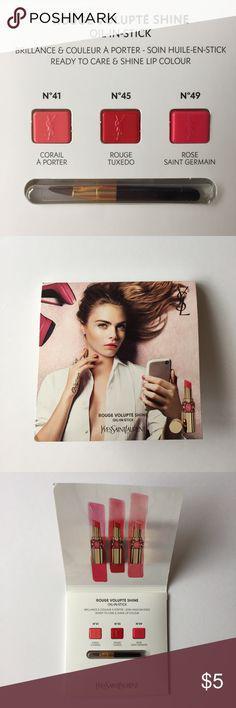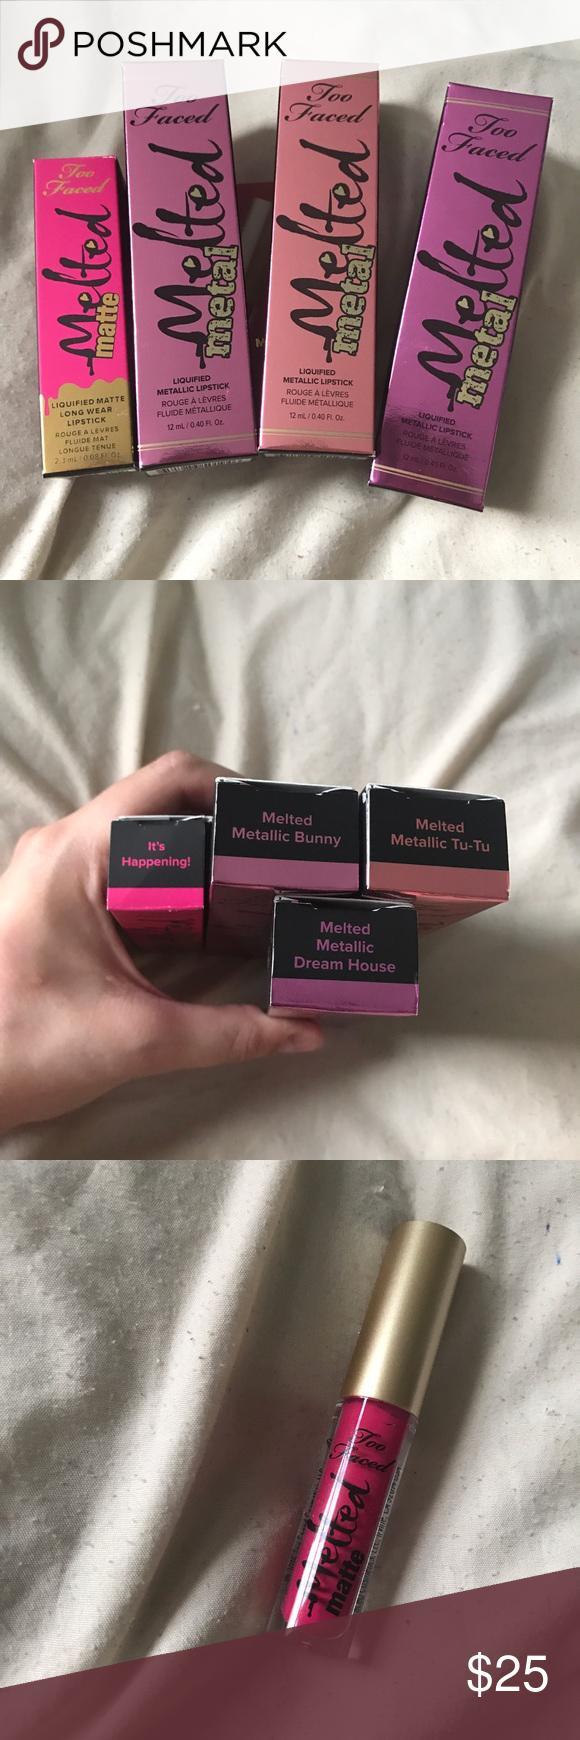The first image is the image on the left, the second image is the image on the right. For the images displayed, is the sentence "Someone is holding some lip stick." factually correct? Answer yes or no. Yes. The first image is the image on the left, the second image is the image on the right. Assess this claim about the two images: "Many shades of reddish lipstick are shown with the caps off in at least one of the pictures.". Correct or not? Answer yes or no. No. 